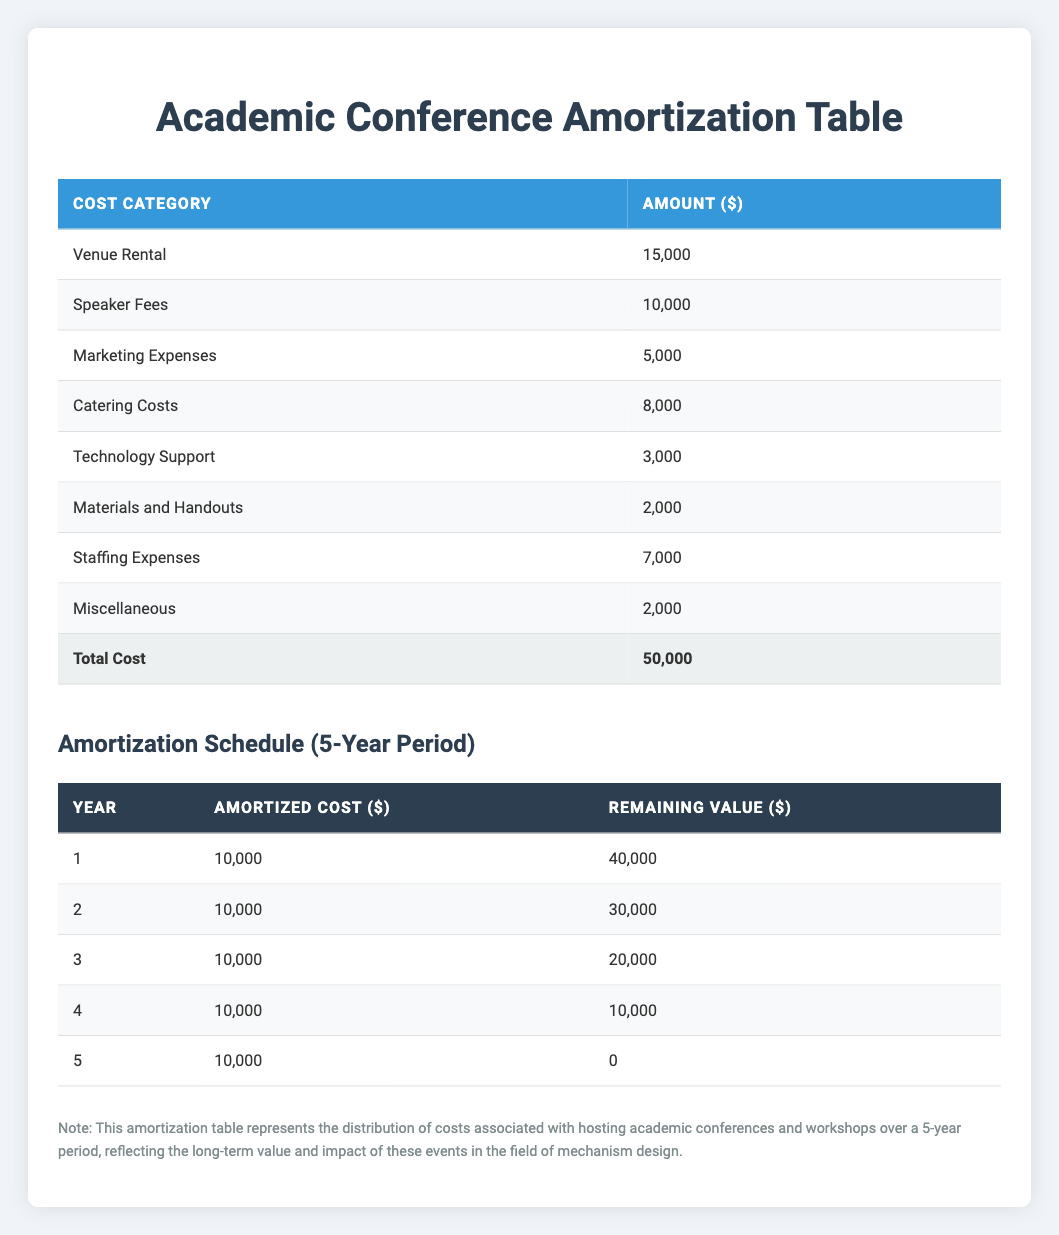What is the total cost associated with hosting the academic conference? The total cost is provided at the end of the initial cost category table, which states the total cost as 50,000.
Answer: 50000 How much are the speaker fees? The speaker fees are listed in the detailed costs section of the table, where they are shown as 10,000.
Answer: 10000 What is the amortized cost in Year 3? Referring to the amortization schedule, Year 3 has an amortized cost listed as 10,000.
Answer: 10000 What are the remaining costs after Year 2? After Year 2, the remaining value is shown as 30,000. This value can be found directly in the amortization schedule under the remaining value for Year 2.
Answer: 30000 Is the catering cost more than the technology support cost? The catering cost is 8,000 and the technology support cost is 3,000. Since 8,000 is greater than 3,000, the statement is true.
Answer: Yes What is the total of the initial investment categories? To find this total, we sum all the individual costs: 15,000 (venue) + 10,000 (speaker) + 5,000 (marketing) + 8,000 (catering) + 3,000 (technology) + 2,000 (materials) + 7,000 (staffing) + 2,000 (miscellaneous) = 50,000. This matches the total cost, confirming the calculation.
Answer: 50000 How much will be amortized over the entire useful life of five years? According to the amortization schedule, each year amortizes 10,000. Over five years, the total amortized cost is 10,000 multiplied by 5, which equals 50,000. This shows the entire cost will be amortized over this period.
Answer: 50000 In which year does the remaining value first drop to zero? By examining the amortization schedule, the remaining value first reaches zero in Year 5. This is indicated in the final row of the schedule for Year 5.
Answer: Year 5 What is the average annual amortization cost? The annual amortization cost is consistently 10,000 across the five years. Summing these values gives 10,000 multiplied by 5 equals 50,000, and then dividing this by the number of years (5) results in an average of 10,000.
Answer: 10000 